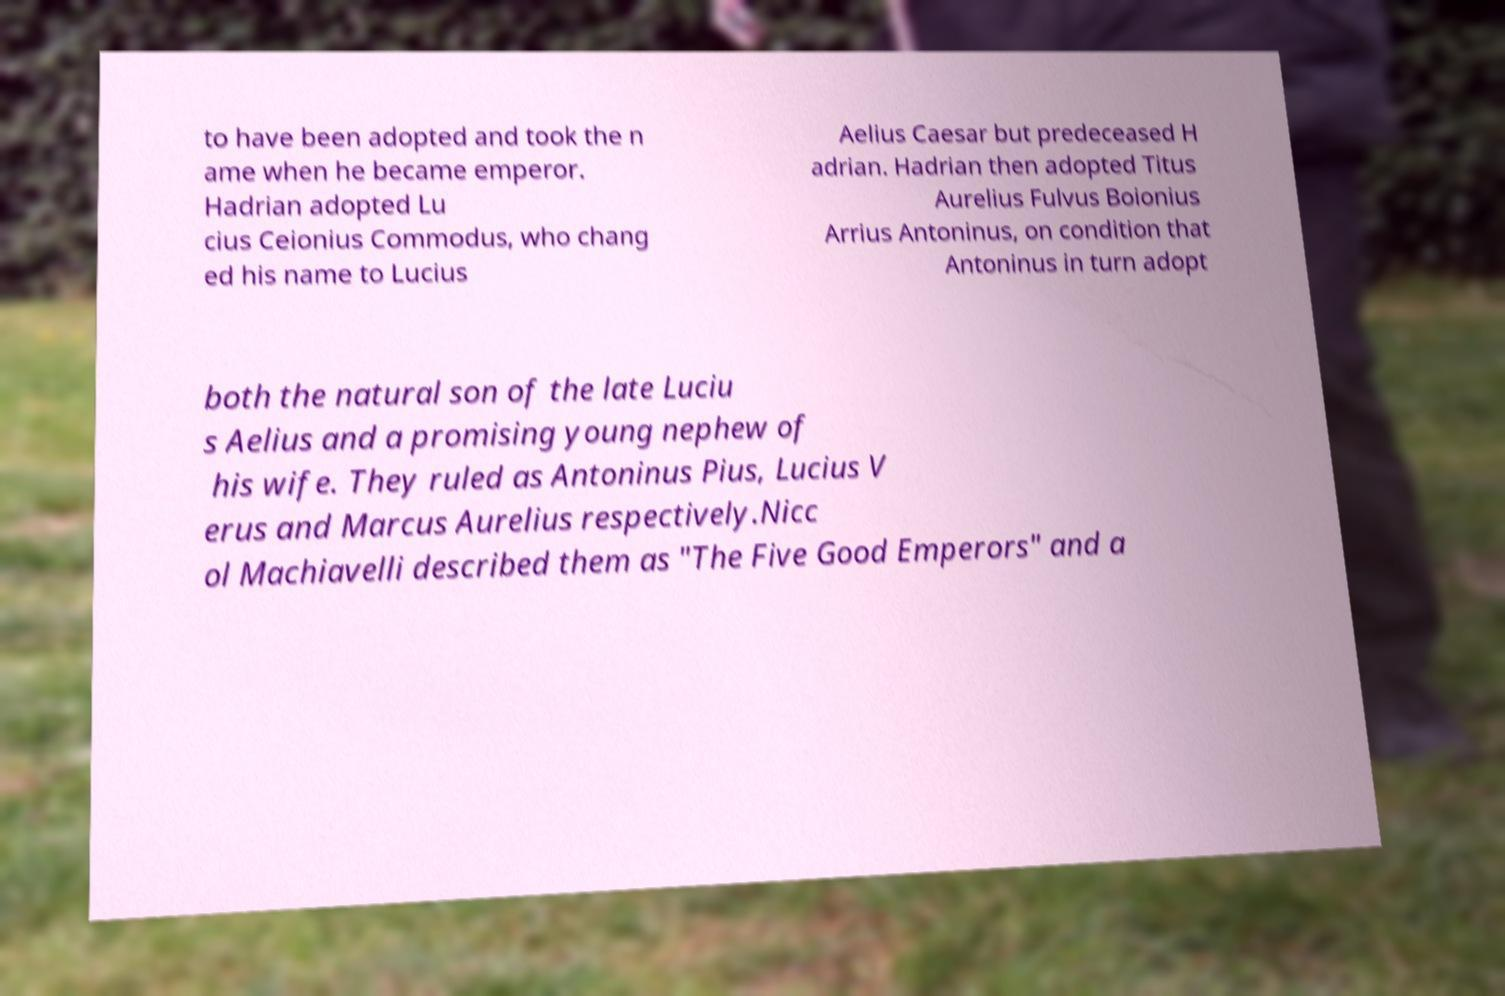Please read and relay the text visible in this image. What does it say? to have been adopted and took the n ame when he became emperor. Hadrian adopted Lu cius Ceionius Commodus, who chang ed his name to Lucius Aelius Caesar but predeceased H adrian. Hadrian then adopted Titus Aurelius Fulvus Boionius Arrius Antoninus, on condition that Antoninus in turn adopt both the natural son of the late Luciu s Aelius and a promising young nephew of his wife. They ruled as Antoninus Pius, Lucius V erus and Marcus Aurelius respectively.Nicc ol Machiavelli described them as "The Five Good Emperors" and a 